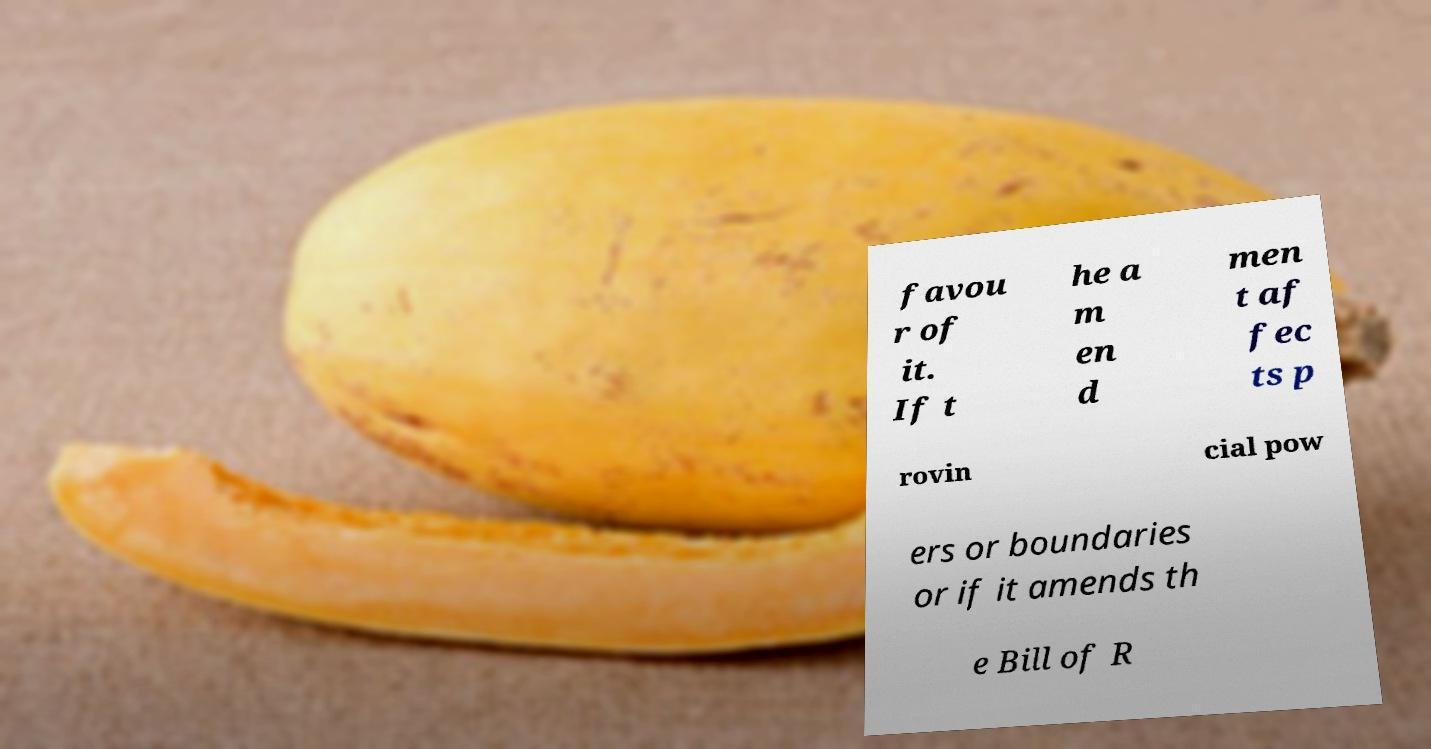Could you assist in decoding the text presented in this image and type it out clearly? favou r of it. If t he a m en d men t af fec ts p rovin cial pow ers or boundaries or if it amends th e Bill of R 